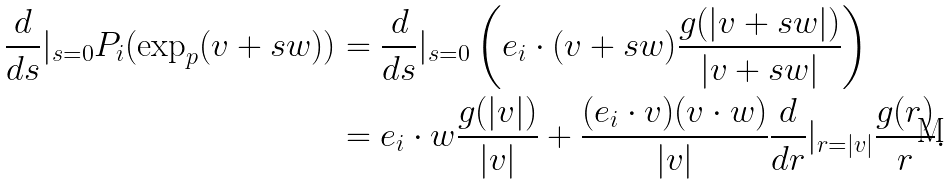<formula> <loc_0><loc_0><loc_500><loc_500>\frac { d } { d s } | _ { s = 0 } P _ { i } ( \exp _ { p } ( v + s w ) ) & = \frac { d } { d s } | _ { s = 0 } \left ( e _ { i } \cdot ( v + s w ) \frac { g ( | v + s w | ) } { | v + s w | } \right ) \\ & = e _ { i } \cdot w \frac { g ( | v | ) } { | v | } + \frac { ( e _ { i } \cdot v ) ( v \cdot w ) } { | v | } { \frac { d } { d r } } | _ { r = | v | } \frac { g ( r ) } { r } .</formula> 